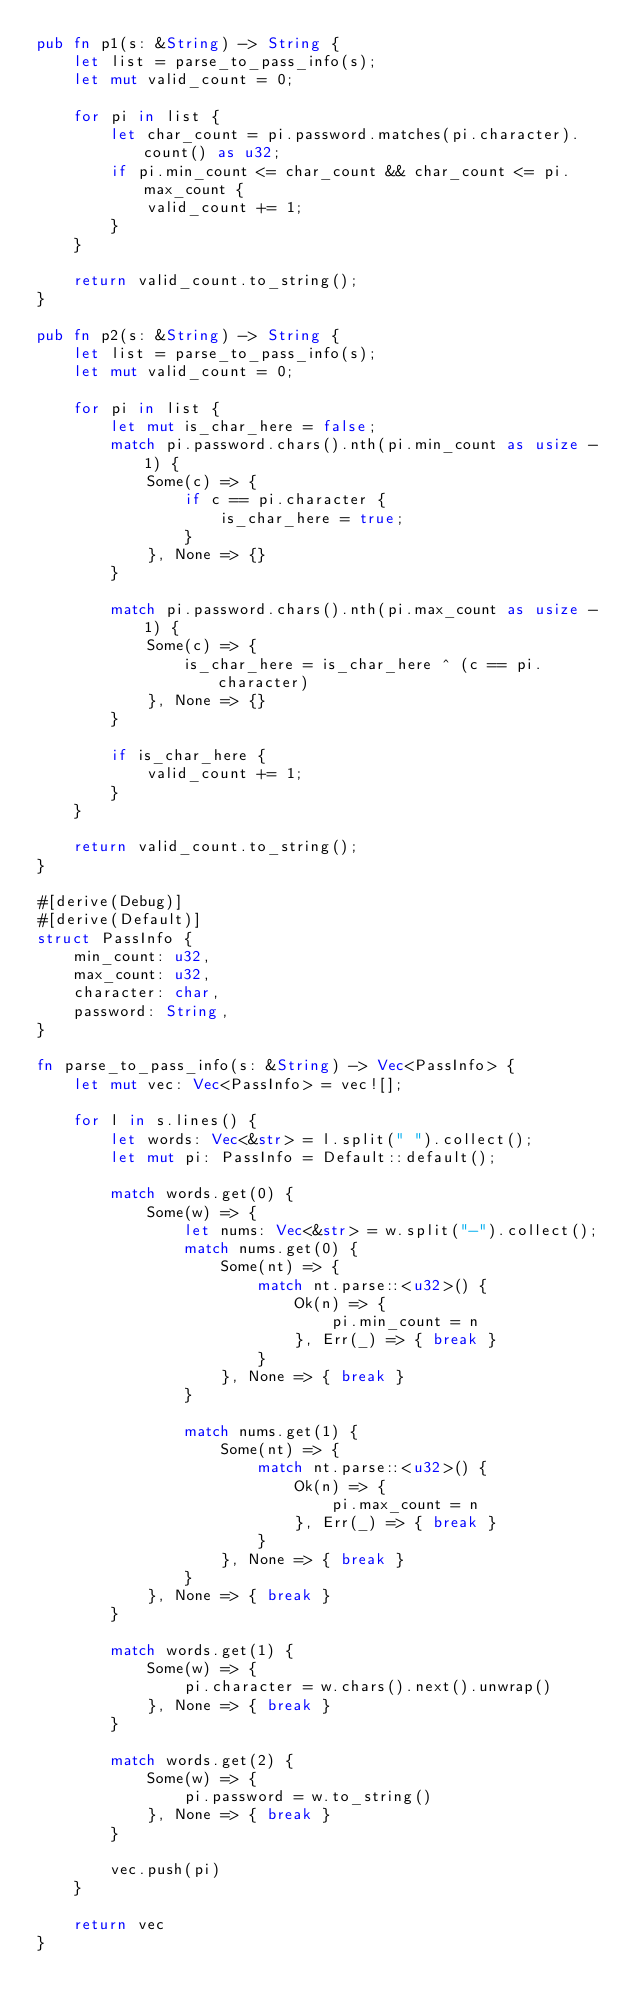Convert code to text. <code><loc_0><loc_0><loc_500><loc_500><_Rust_>pub fn p1(s: &String) -> String {
    let list = parse_to_pass_info(s);
    let mut valid_count = 0;

    for pi in list {
        let char_count = pi.password.matches(pi.character).count() as u32;
        if pi.min_count <= char_count && char_count <= pi.max_count {
            valid_count += 1;
        }
    }

    return valid_count.to_string();
}

pub fn p2(s: &String) -> String {
    let list = parse_to_pass_info(s);
    let mut valid_count = 0;

    for pi in list {
        let mut is_char_here = false;
        match pi.password.chars().nth(pi.min_count as usize - 1) {
            Some(c) => {
                if c == pi.character {
                    is_char_here = true;
                }
            }, None => {}
        }

        match pi.password.chars().nth(pi.max_count as usize - 1) {
            Some(c) => {
                is_char_here = is_char_here ^ (c == pi.character)
            }, None => {}
        }

        if is_char_here {
            valid_count += 1;
        }
    }

    return valid_count.to_string();
}

#[derive(Debug)]
#[derive(Default)]
struct PassInfo {
    min_count: u32,
    max_count: u32,
    character: char,
    password: String,
}

fn parse_to_pass_info(s: &String) -> Vec<PassInfo> {
    let mut vec: Vec<PassInfo> = vec![];

    for l in s.lines() {
        let words: Vec<&str> = l.split(" ").collect();
        let mut pi: PassInfo = Default::default();

        match words.get(0) {
            Some(w) => {
                let nums: Vec<&str> = w.split("-").collect();
                match nums.get(0) {
                    Some(nt) => {
                        match nt.parse::<u32>() {
                            Ok(n) => {
                                pi.min_count = n
                            }, Err(_) => { break }
                        }
                    }, None => { break }
                }

                match nums.get(1) {
                    Some(nt) => {
                        match nt.parse::<u32>() {
                            Ok(n) => {
                                pi.max_count = n
                            }, Err(_) => { break }
                        }
                    }, None => { break }
                }
            }, None => { break }
        }

        match words.get(1) {
            Some(w) => {
                pi.character = w.chars().next().unwrap()
            }, None => { break }
        }

        match words.get(2) {
            Some(w) => {
                pi.password = w.to_string()
            }, None => { break }
        }

        vec.push(pi)
    }

    return vec
}
</code> 